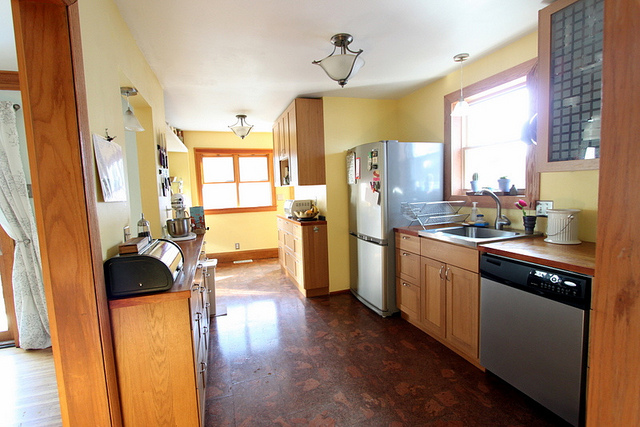<image>Why was this picture taken? It is ambiguous as to why this picture was taken. It could be for real estate purposes or to show the kitchen. Why was this picture taken? I don't know why this picture was taken. It can be for renting, selling the house or showing the kitchen for real estate purposes. 